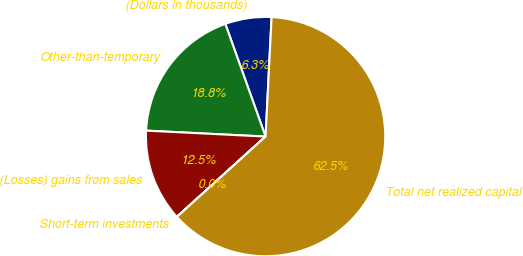Convert chart. <chart><loc_0><loc_0><loc_500><loc_500><pie_chart><fcel>(Dollars in thousands)<fcel>Other-than-temporary<fcel>(Losses) gains from sales<fcel>Short-term investments<fcel>Total net realized capital<nl><fcel>6.26%<fcel>18.75%<fcel>12.5%<fcel>0.01%<fcel>62.48%<nl></chart> 